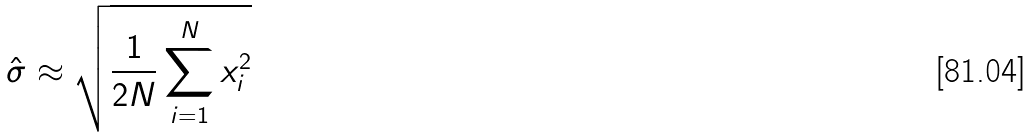Convert formula to latex. <formula><loc_0><loc_0><loc_500><loc_500>\hat { \sigma } \approx \sqrt { \frac { 1 } { 2 N } \sum _ { i = 1 } ^ { N } x _ { i } ^ { 2 } }</formula> 